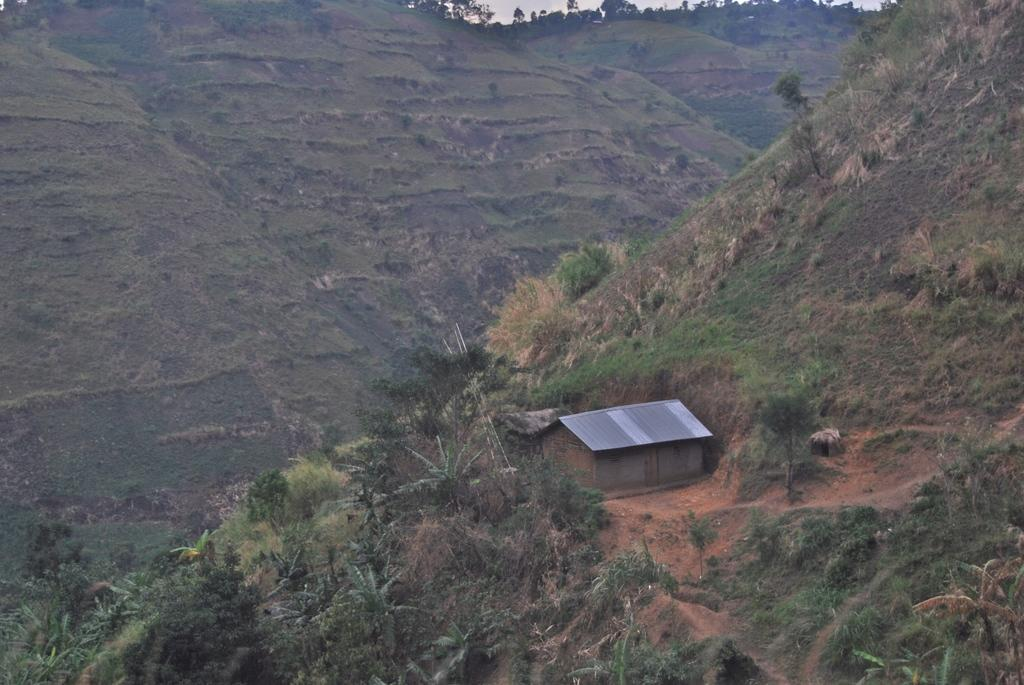What type of natural landscape is depicted in the image? There are hills in the image. What can be found on the hills in the image? The hills have trees and plants. Is there any sign of human habitation on the hills? Yes, there is a house on one of the hills. What type of industry can be seen operating on the hills in the image? There is no industry present in the image; it features hills with trees and plants, a house, and no signs of industrial activity. 